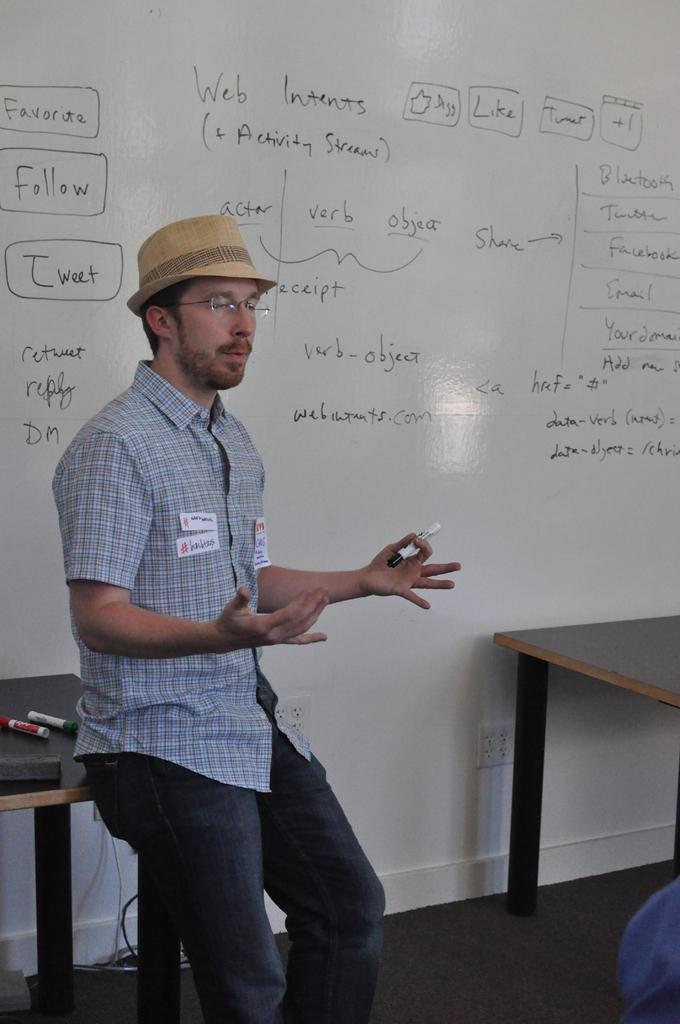<image>
Offer a succinct explanation of the picture presented. A man is in the front of a room with writing on the wall behind him such as Web Intents (+ Activity Streams). 